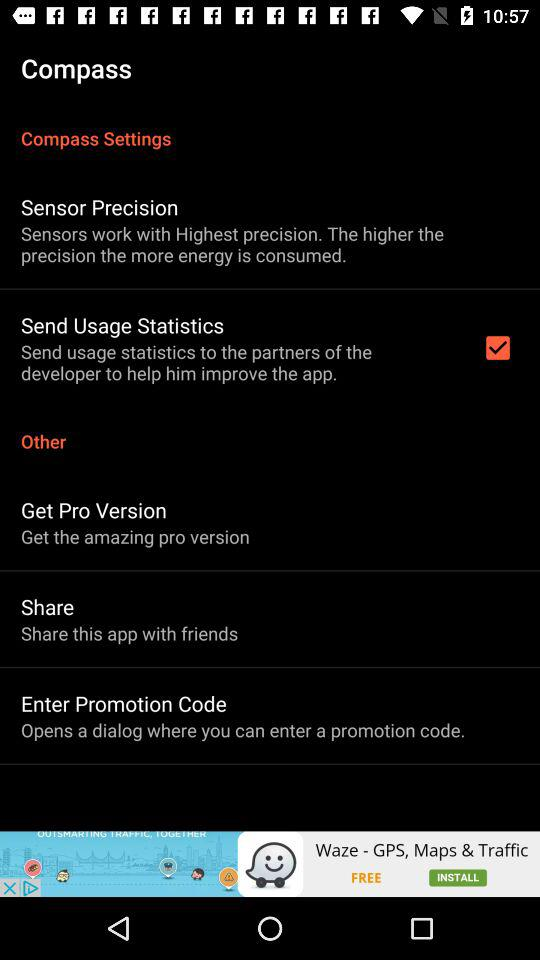What is the name of the application? The name of the application is "Compass". 